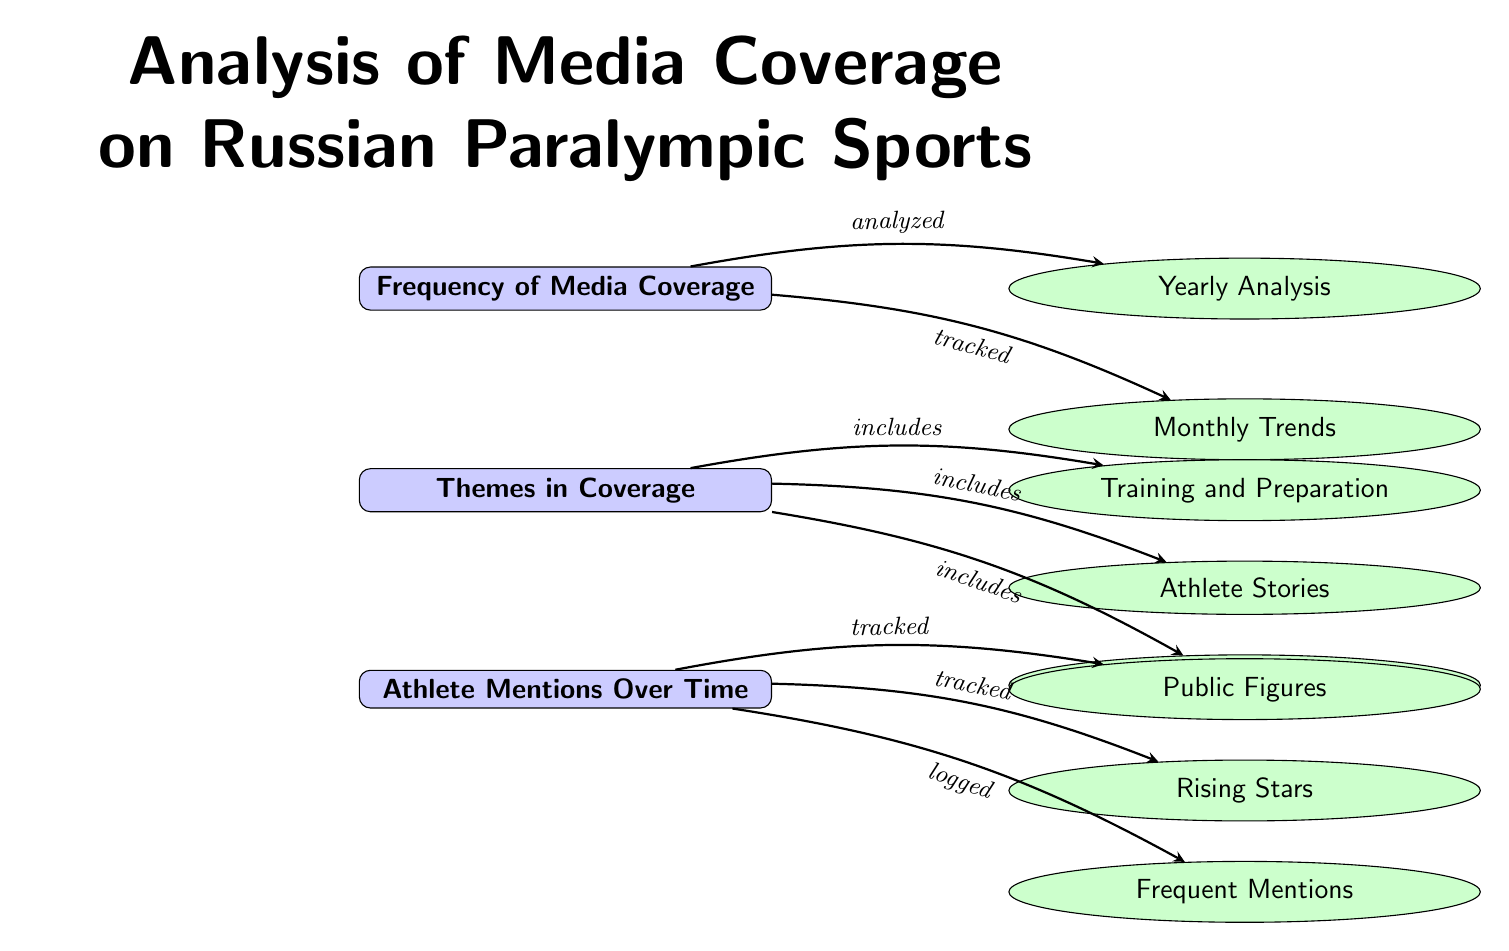What is the title of the diagram? The title is positioned at the top of the diagram, indicating the subject of the analysis, which is emphasized in bold and a larger font size. The title states “Analysis of Media Coverage on Russian Paralympic Sports.”
Answer: Analysis of Media Coverage on Russian Paralympic Sports How many main categories are in the diagram? Counting the main categories, there are three nodes stacked vertically: Frequency of Media Coverage, Themes in Coverage, and Athlete Mentions Over Time, which makes the total three.
Answer: 3 What subcategory is related to Frequency of Media Coverage? The subcategories branching from Frequency of Media Coverage include Yearly Analysis and Monthly Trends, which are both positioned to the right of the main category indicating their direct relationship.
Answer: Yearly Analysis Which themes are included under Themes in Coverage? The themes are listed as subcategories beneath Themes in Coverage, explicitly they are Training and Preparation, Athlete Stories, and Competitions and Results, all directly linked to the main category.
Answer: Training and Preparation, Athlete Stories, Competitions and Results Which subcategory is tracked under Athlete Mentions Over Time? The subcategories that stem from Athlete Mentions Over Time include Public Figures, Rising Stars, and Frequent Mentions, showing the specific focus areas analyzed in mentions.
Answer: Public Figures Is there a relationship between Themes in Coverage and Frequency of Media Coverage? Yes, there is a directed edge connecting these two categories, indicating that the analysis of themes also corresponds to how frequently they appear in media coverage.
Answer: Yes What does the edge between Mentions and Public Figures signify? The edge indicates that mentions of public figures are being tracked over time, which suggests data collection related to how often these figures are cited in discussions surrounding Paralympic sports.
Answer: Tracked Which area of analysis focuses on the trends over a month? The right subcategory of Frequency of Media Coverage is labeled Monthly Trends, specifically addressing the analysis of trends on a monthly basis regarding media coverage.
Answer: Monthly Trends Which subcategory is positioned below Athlete Stories? Directly below Athlete Stories is the subcategory Competitions and Results, showing a hierarchy within the themes in coverage of sports.
Answer: Competitions and Results 